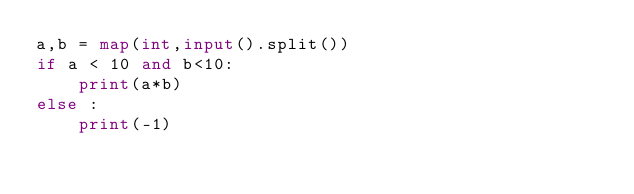<code> <loc_0><loc_0><loc_500><loc_500><_Python_>a,b = map(int,input().split())
if a < 10 and b<10:
    print(a*b)
else :
    print(-1)</code> 